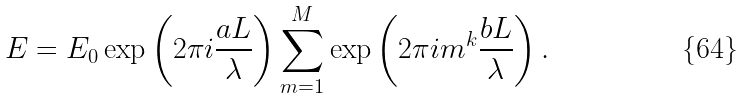Convert formula to latex. <formula><loc_0><loc_0><loc_500><loc_500>E = E _ { 0 } \exp \left ( 2 \pi i \frac { a L } { \lambda } \right ) \sum _ { m = 1 } ^ { M } \exp \left ( 2 \pi i m ^ { k } \frac { b L } { \lambda } \right ) .</formula> 